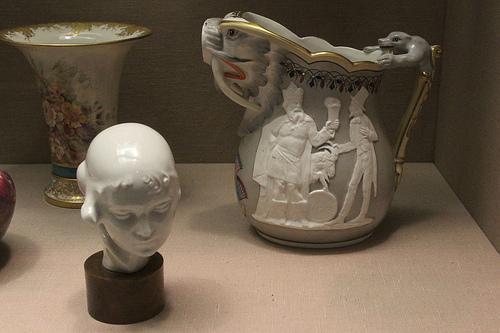How many things are there?
Give a very brief answer. 3. 